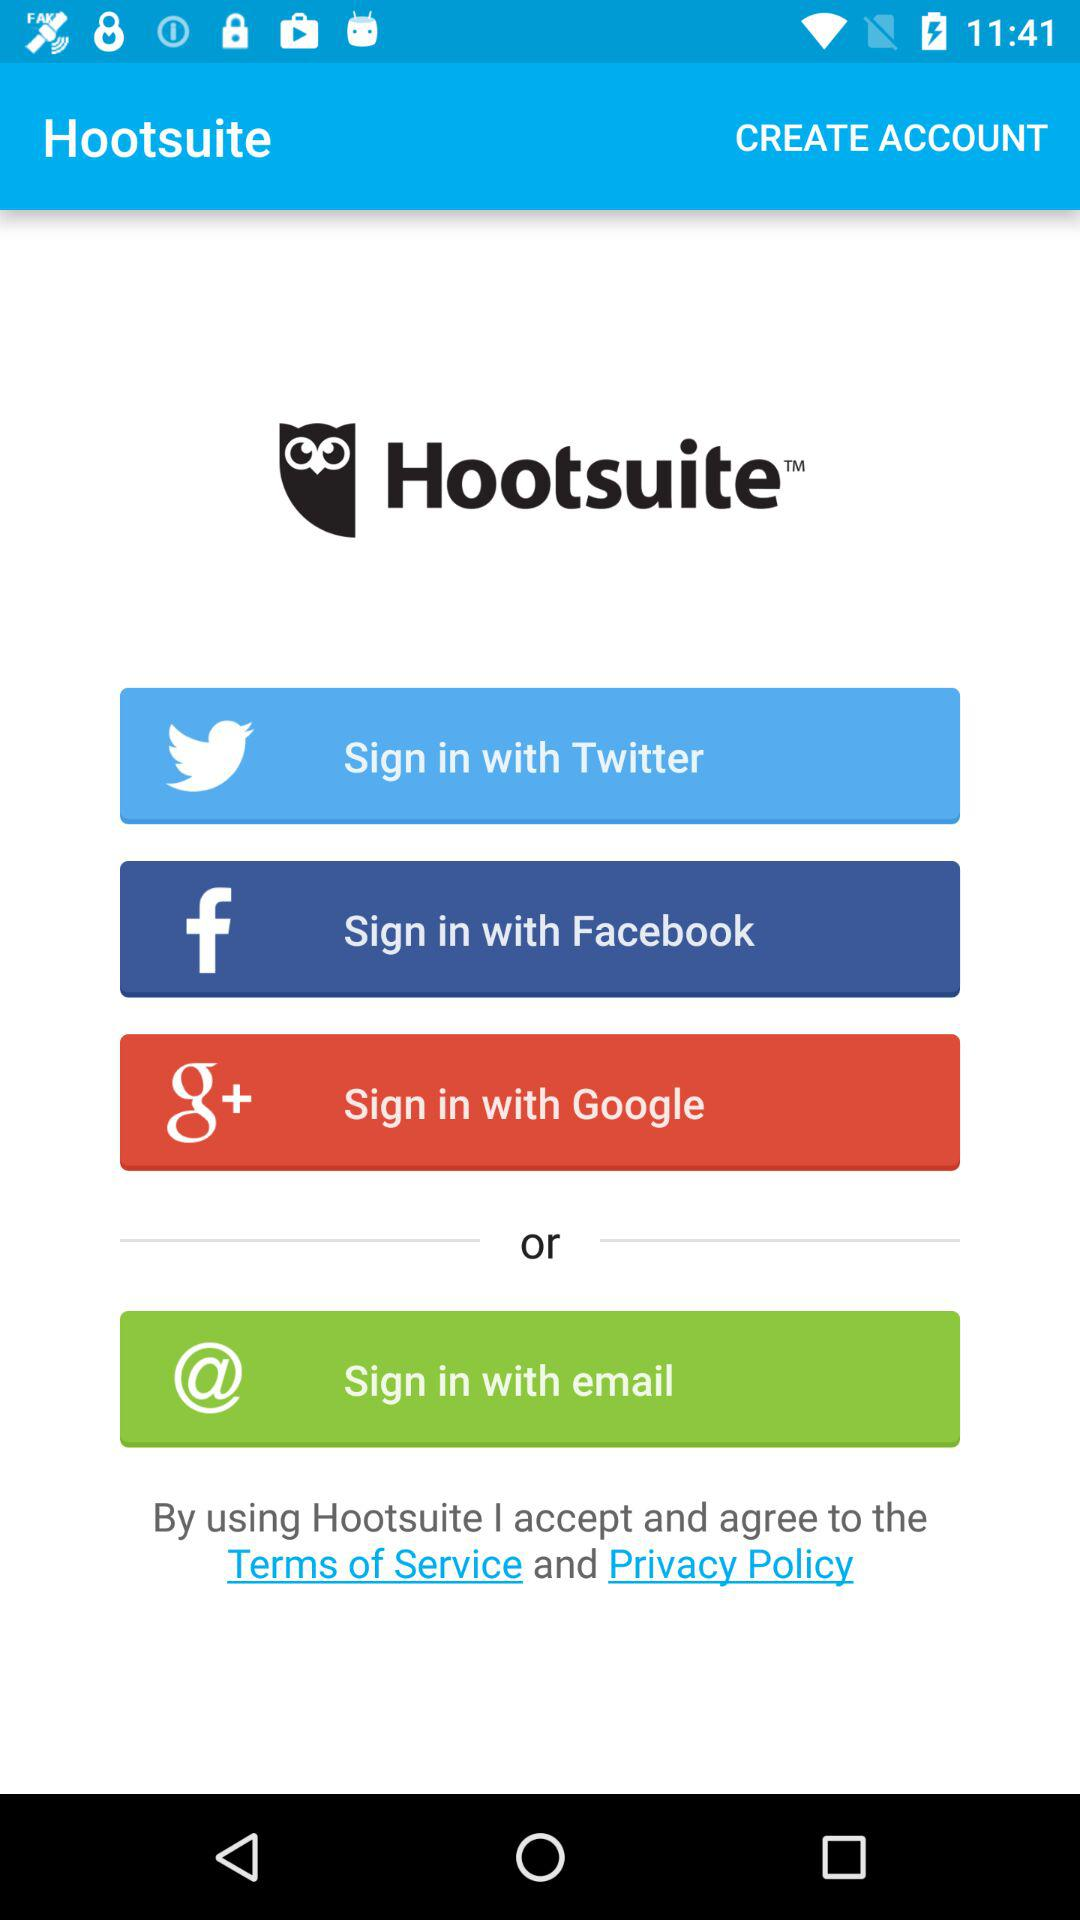What is the application name? The application name is "Hootsuite". 